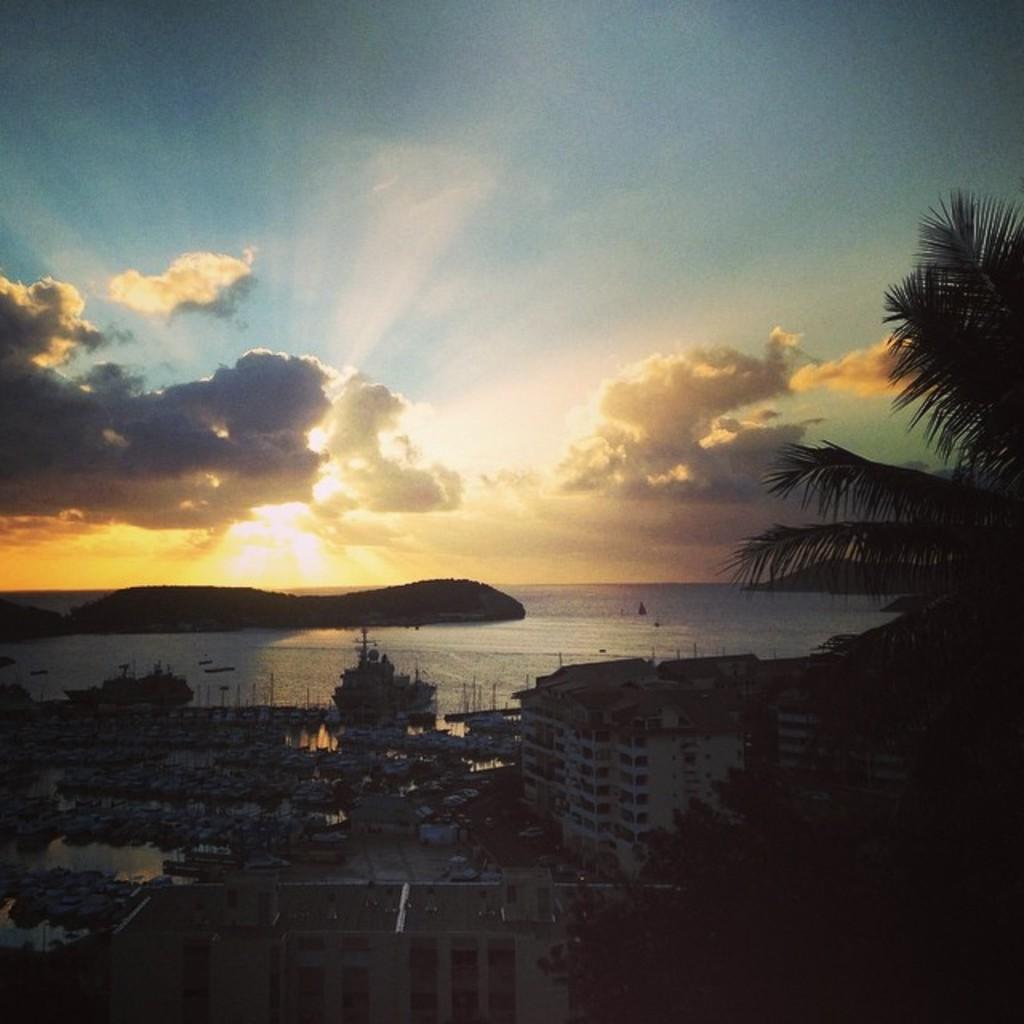How would you summarize this image in a sentence or two? This image is taken during the evening time. In this image we can see the buildings, trees, hills and also the boats on the surface of the water. In the background we can see the sky with the clouds. 